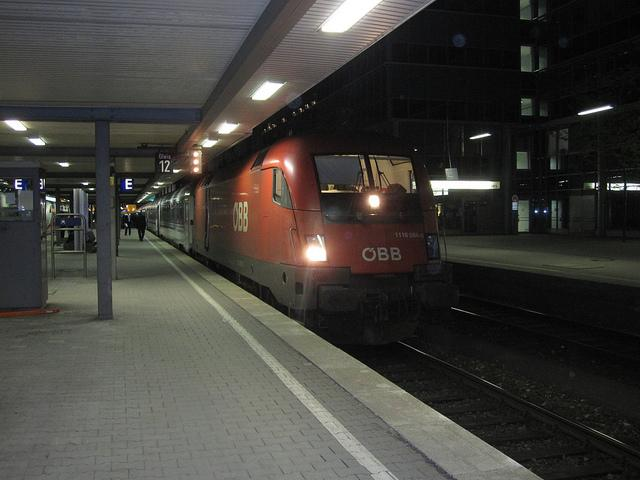What letter appears twice in a row on the train? Please explain your reasoning. b. Obb appears on the train. 